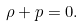<formula> <loc_0><loc_0><loc_500><loc_500>\rho + p = 0 .</formula> 